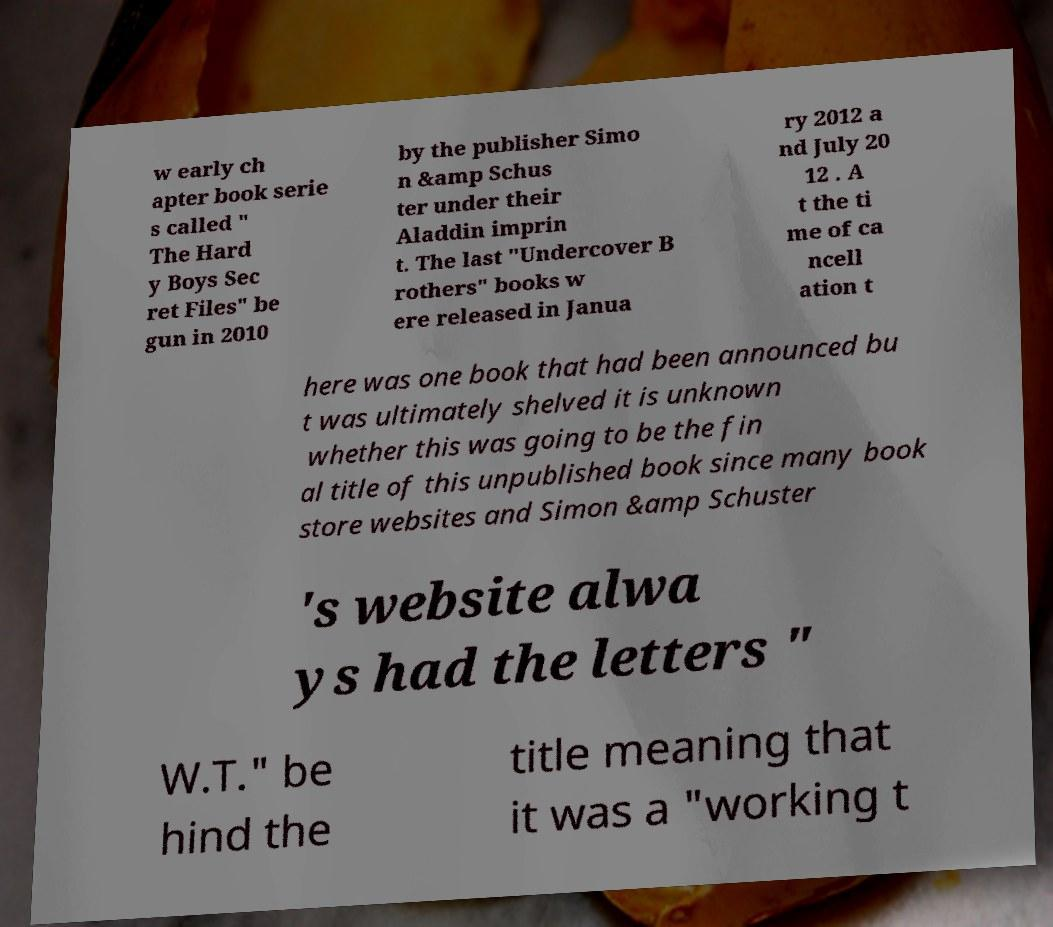Could you assist in decoding the text presented in this image and type it out clearly? w early ch apter book serie s called " The Hard y Boys Sec ret Files" be gun in 2010 by the publisher Simo n &amp Schus ter under their Aladdin imprin t. The last "Undercover B rothers" books w ere released in Janua ry 2012 a nd July 20 12 . A t the ti me of ca ncell ation t here was one book that had been announced bu t was ultimately shelved it is unknown whether this was going to be the fin al title of this unpublished book since many book store websites and Simon &amp Schuster 's website alwa ys had the letters " W.T." be hind the title meaning that it was a "working t 